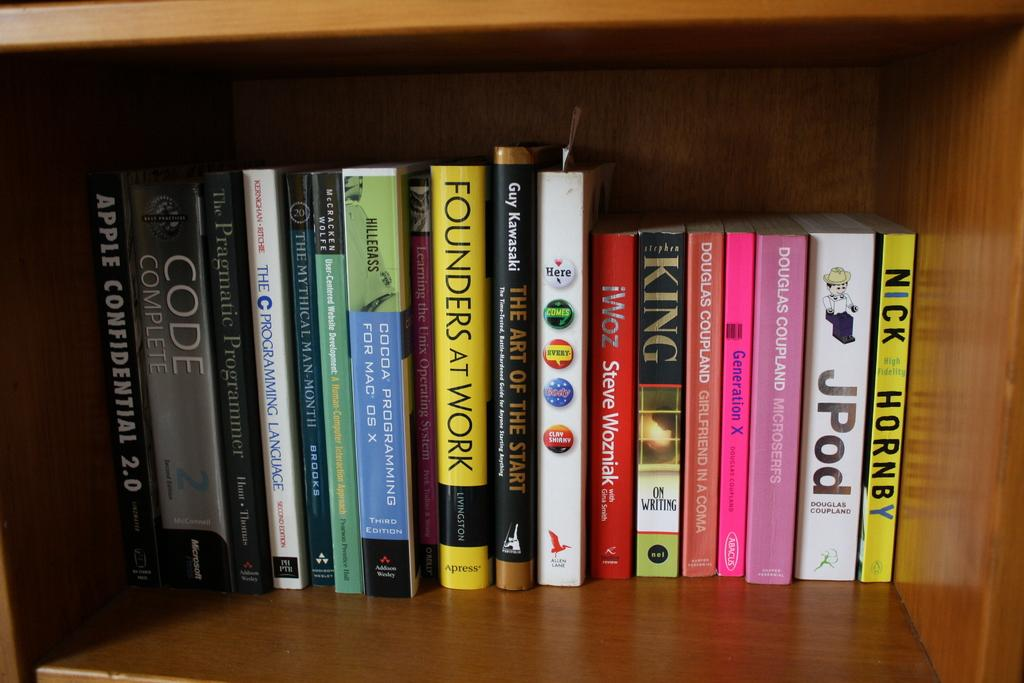<image>
Describe the image concisely. nick hornby is the author of one of the books that are lines up on the shelf 